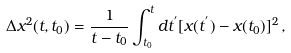Convert formula to latex. <formula><loc_0><loc_0><loc_500><loc_500>\Delta x ^ { 2 } ( t , t _ { 0 } ) = \frac { 1 } { t - t _ { 0 } } \int ^ { t } _ { t _ { 0 } } d t ^ { ^ { \prime } } [ x ( t ^ { ^ { \prime } } ) - x ( t _ { 0 } ) ] ^ { 2 } \, ,</formula> 